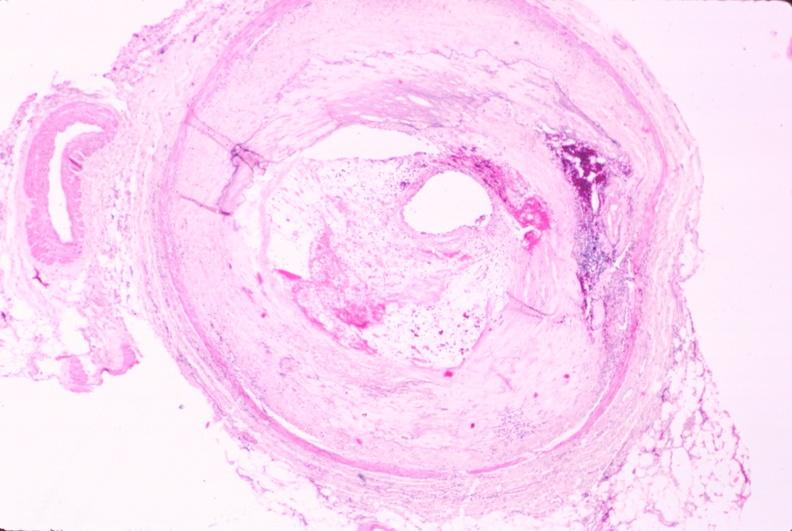where is this in?
Answer the question using a single word or phrase. In vasculature 